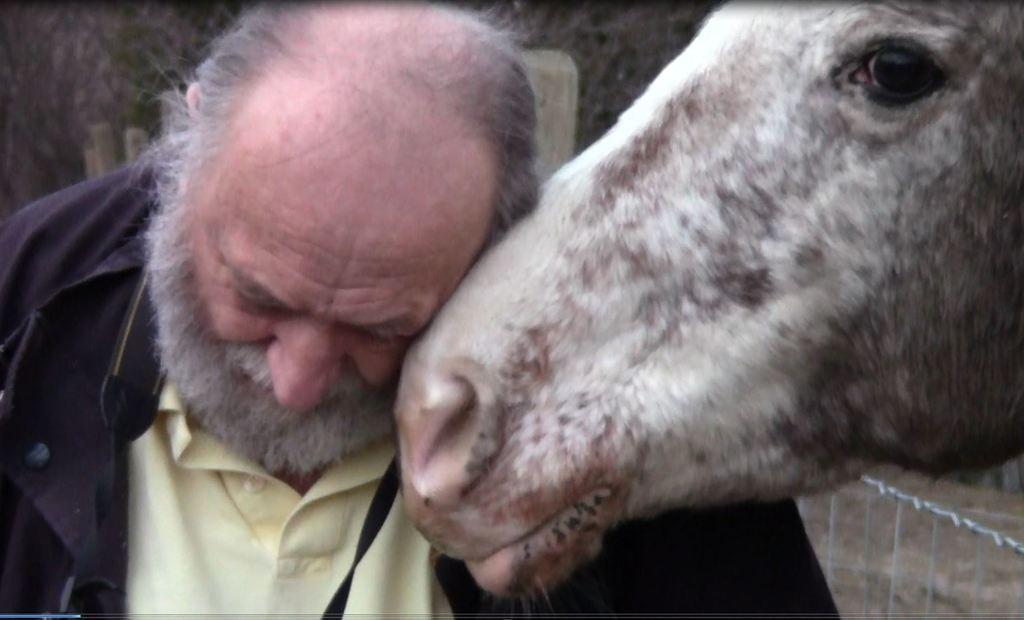Can you describe this image briefly? On the right side of this image I can see an animal´s head. On the left side there is a man wearing a black color jacket and looking at the downwards. In the background there are some trees. In the bottom right there is a railing. 